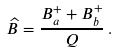Convert formula to latex. <formula><loc_0><loc_0><loc_500><loc_500>\widehat { B } = \frac { B _ { a } ^ { + } + B _ { b } ^ { + } } { Q } \, .</formula> 